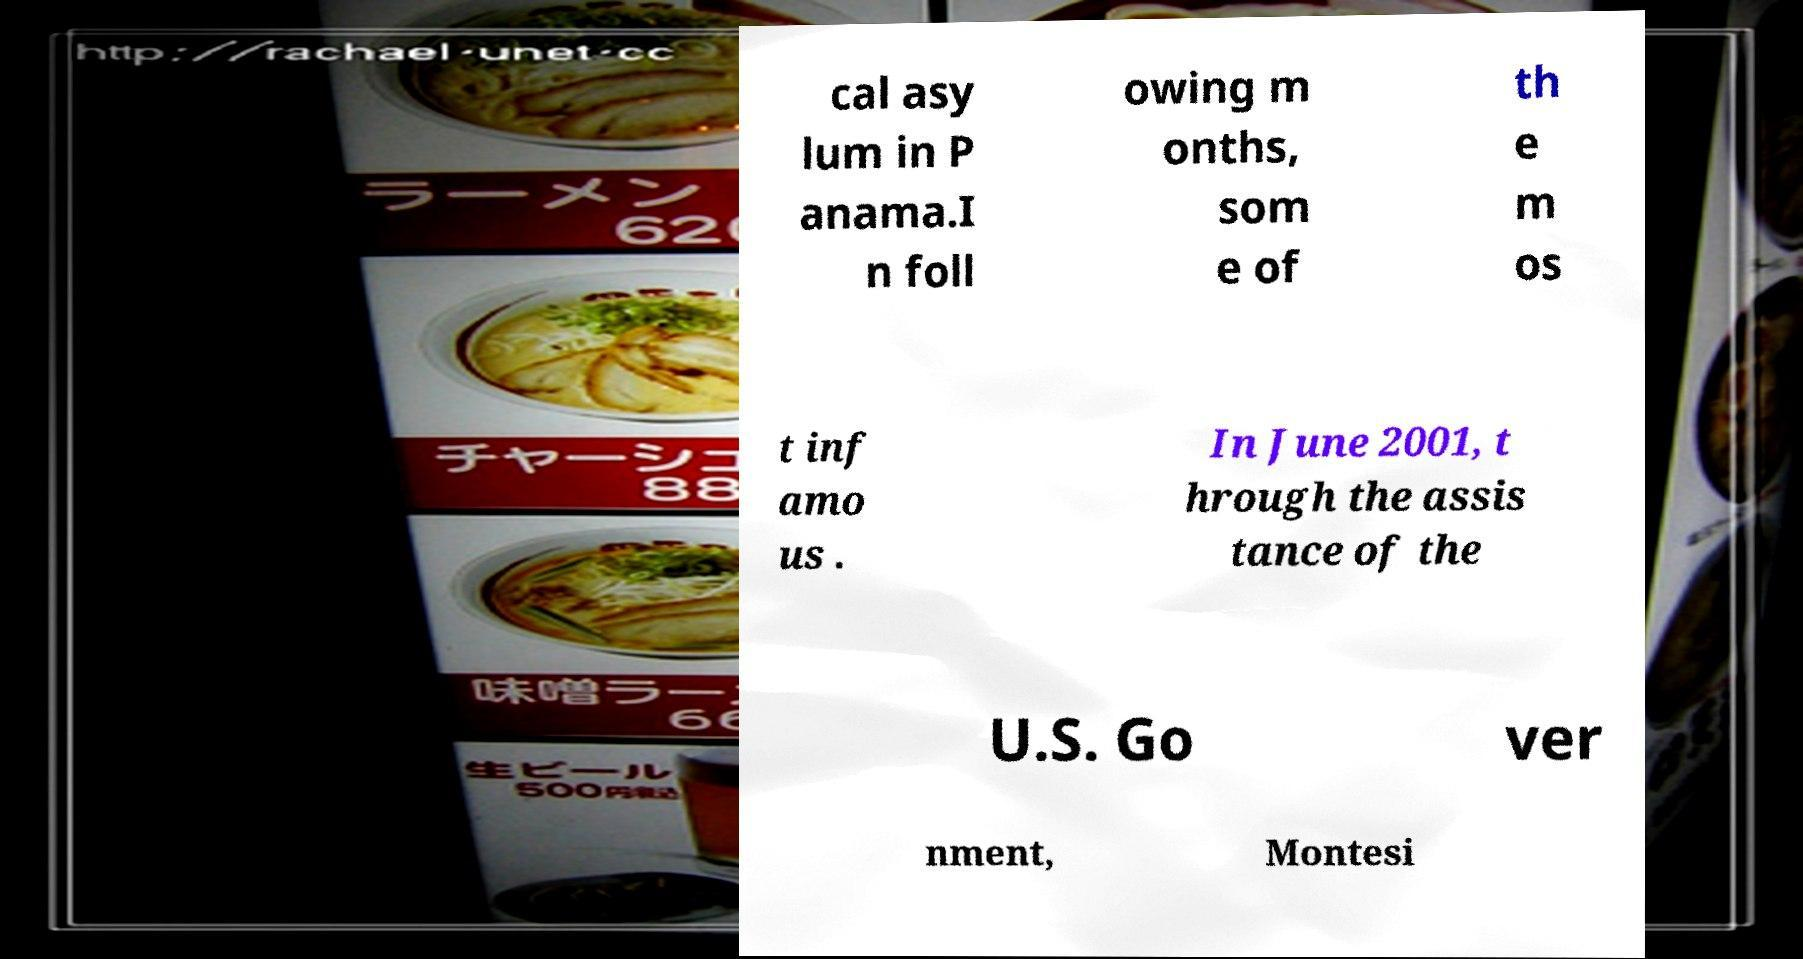What messages or text are displayed in this image? I need them in a readable, typed format. cal asy lum in P anama.I n foll owing m onths, som e of th e m os t inf amo us . In June 2001, t hrough the assis tance of the U.S. Go ver nment, Montesi 